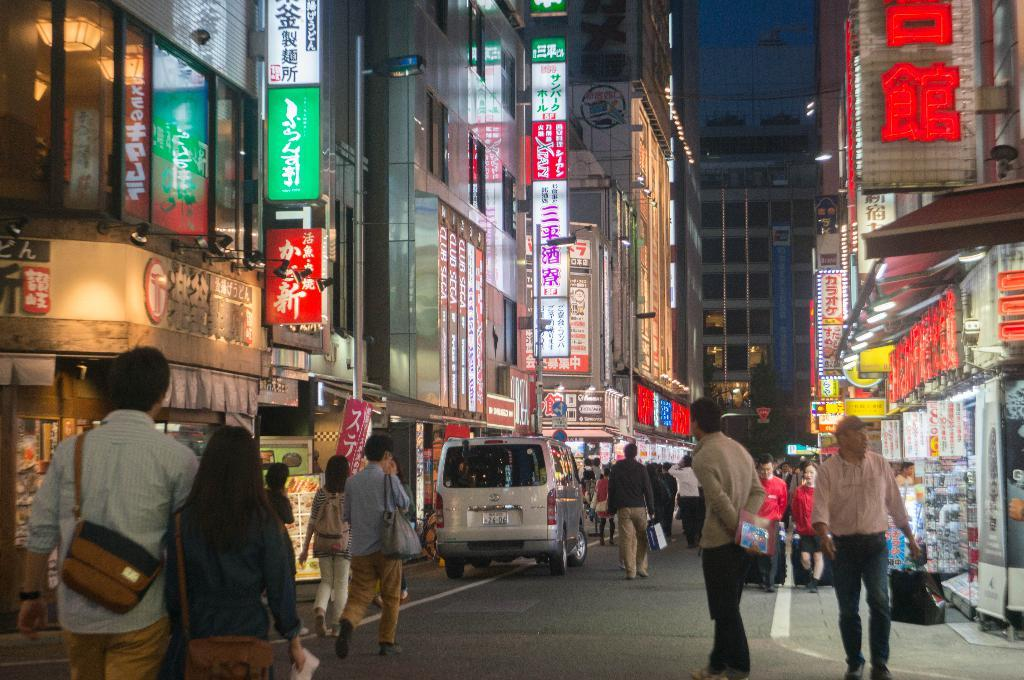What type of structures can be seen in the image? There are buildings in the image. What feature is common among many of the buildings? There are glass windows in the buildings. What type of establishments can be found in the image? There are stores in the image. What type of signage is present in the image? Banners are present in the image. What type of display boards are visible in the image? Boards are visible in the image. What type of illumination is present in the image? Lights are present in the image. What type of transportation is visible in the image? Vehicles are visible in the image. What type of activity is happening in the image? There are people walking in the image. What type of accessory are some people wearing in the image? Some people in the image are wearing bags. What type of fowl can be seen walking in the image? There are no fowl present in the image; only people are walking. What type of suit is visible on the grain in the image? There is no suit present in the image, and there is no grain either. 